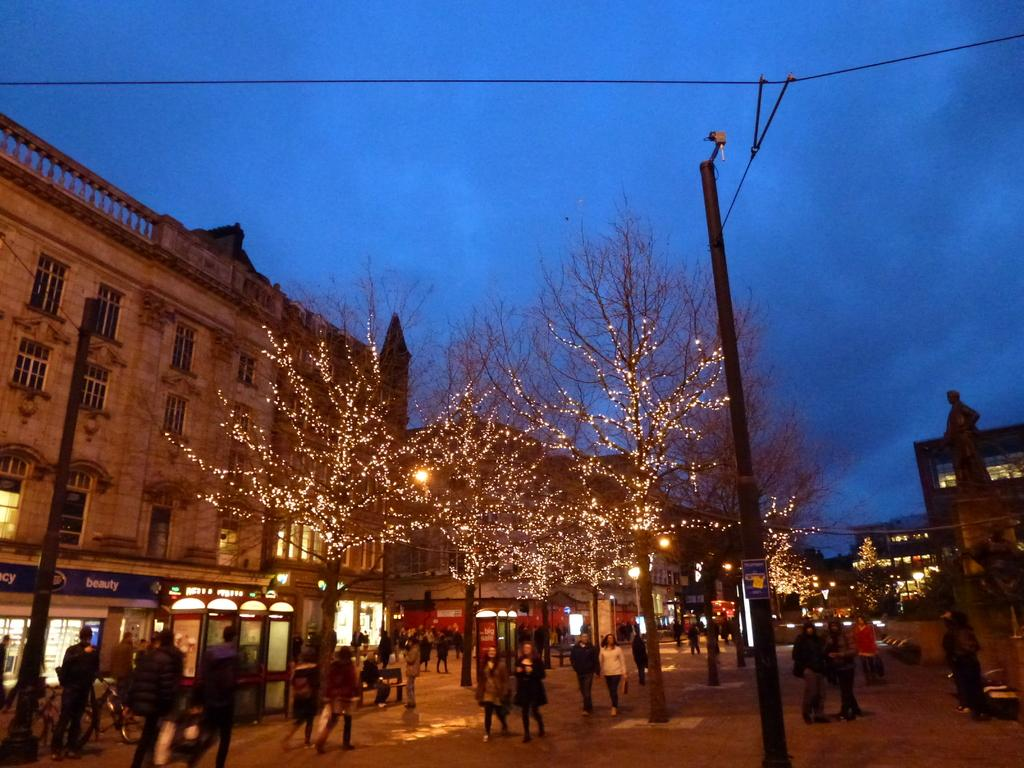What type of natural elements can be seen in the image? There are trees in the image. What type of artificial elements can be seen in the image? There are street lamps, buildings, and a pole in the image. Are there any living beings present in the image? Yes, there are people and a bird in the image. What is visible in the sky in the image? The sky is visible in the image. How would you describe the lighting conditions in the image? The image is described as being a little dark. What type of pollution is visible in the image? There is no pollution visible in the image. What type of boundary is present in the image? There is no boundary present in the image. 